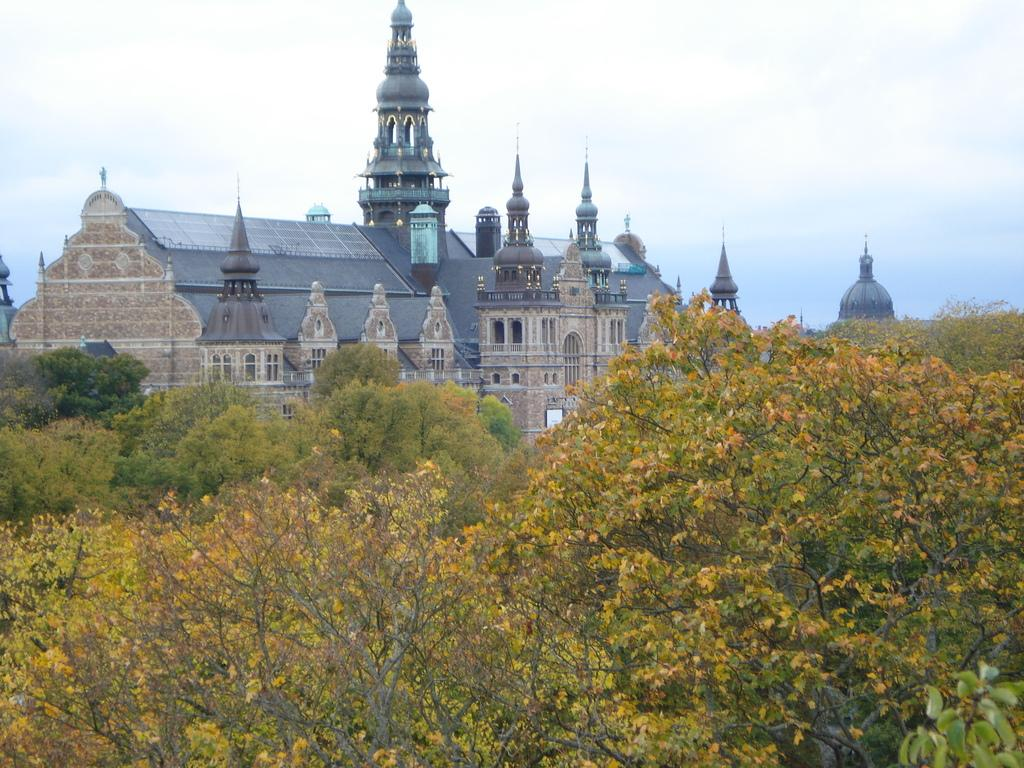What is the main structure in the middle of the image? There is a castle in the middle of the image. What can be seen at the bottom of the image? There are many plants at the bottom of the image. How are the plants arranged in the image? The plants are arranged one beside the other. What is visible at the top of the image? The sky is visible at the top of the image. What sound does the toad make in the image? There is no toad present in the image, so it is not possible to determine the sound it might make. 